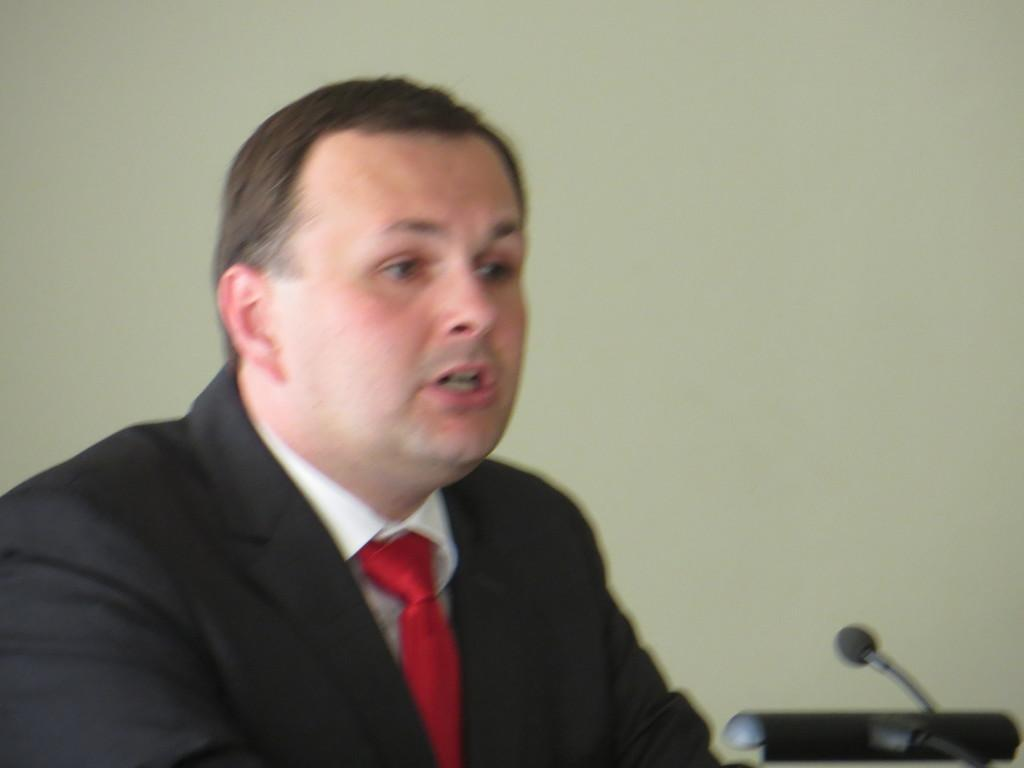Who or what is the main subject in the image? There is a person in the image. What object is in front of the person? There is a microphone in front of the person. What is visible behind the person? There is a wall behind the person. Can you see any hills in the image? There are no hills visible in the image. How many men are present in the image? The image only features one person, so there is only one person, not multiple men. 